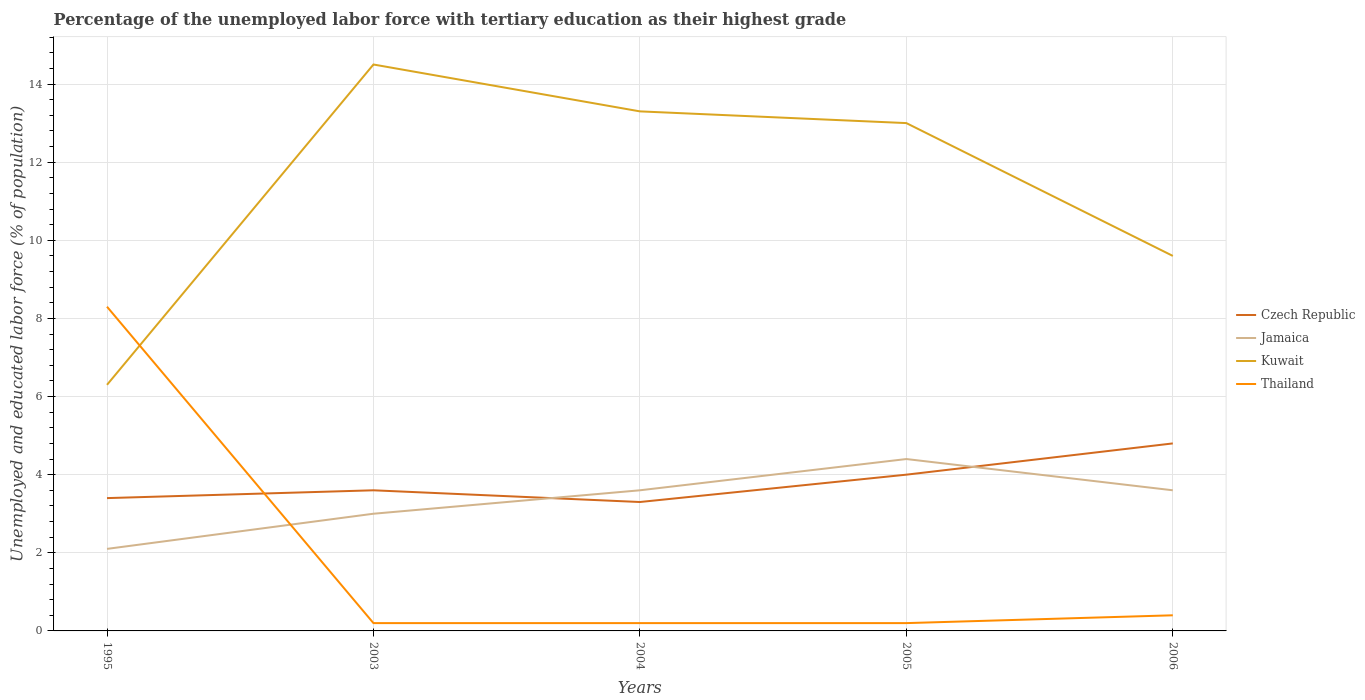How many different coloured lines are there?
Keep it short and to the point. 4. Across all years, what is the maximum percentage of the unemployed labor force with tertiary education in Thailand?
Give a very brief answer. 0.2. In which year was the percentage of the unemployed labor force with tertiary education in Jamaica maximum?
Your response must be concise. 1995. What is the total percentage of the unemployed labor force with tertiary education in Czech Republic in the graph?
Provide a succinct answer. 0.3. What is the difference between the highest and the second highest percentage of the unemployed labor force with tertiary education in Czech Republic?
Your answer should be compact. 1.5. How many years are there in the graph?
Ensure brevity in your answer.  5. Are the values on the major ticks of Y-axis written in scientific E-notation?
Provide a short and direct response. No. How many legend labels are there?
Your response must be concise. 4. What is the title of the graph?
Provide a short and direct response. Percentage of the unemployed labor force with tertiary education as their highest grade. What is the label or title of the X-axis?
Ensure brevity in your answer.  Years. What is the label or title of the Y-axis?
Keep it short and to the point. Unemployed and educated labor force (% of population). What is the Unemployed and educated labor force (% of population) of Czech Republic in 1995?
Keep it short and to the point. 3.4. What is the Unemployed and educated labor force (% of population) of Jamaica in 1995?
Keep it short and to the point. 2.1. What is the Unemployed and educated labor force (% of population) in Kuwait in 1995?
Keep it short and to the point. 6.3. What is the Unemployed and educated labor force (% of population) of Thailand in 1995?
Provide a succinct answer. 8.3. What is the Unemployed and educated labor force (% of population) of Czech Republic in 2003?
Your answer should be compact. 3.6. What is the Unemployed and educated labor force (% of population) in Jamaica in 2003?
Your answer should be very brief. 3. What is the Unemployed and educated labor force (% of population) of Kuwait in 2003?
Keep it short and to the point. 14.5. What is the Unemployed and educated labor force (% of population) of Thailand in 2003?
Keep it short and to the point. 0.2. What is the Unemployed and educated labor force (% of population) in Czech Republic in 2004?
Your response must be concise. 3.3. What is the Unemployed and educated labor force (% of population) of Jamaica in 2004?
Ensure brevity in your answer.  3.6. What is the Unemployed and educated labor force (% of population) of Kuwait in 2004?
Provide a short and direct response. 13.3. What is the Unemployed and educated labor force (% of population) of Thailand in 2004?
Offer a terse response. 0.2. What is the Unemployed and educated labor force (% of population) in Jamaica in 2005?
Your answer should be very brief. 4.4. What is the Unemployed and educated labor force (% of population) in Kuwait in 2005?
Offer a very short reply. 13. What is the Unemployed and educated labor force (% of population) of Thailand in 2005?
Your answer should be very brief. 0.2. What is the Unemployed and educated labor force (% of population) of Czech Republic in 2006?
Offer a terse response. 4.8. What is the Unemployed and educated labor force (% of population) of Jamaica in 2006?
Your answer should be compact. 3.6. What is the Unemployed and educated labor force (% of population) of Kuwait in 2006?
Provide a succinct answer. 9.6. What is the Unemployed and educated labor force (% of population) in Thailand in 2006?
Your answer should be compact. 0.4. Across all years, what is the maximum Unemployed and educated labor force (% of population) of Czech Republic?
Keep it short and to the point. 4.8. Across all years, what is the maximum Unemployed and educated labor force (% of population) of Jamaica?
Provide a succinct answer. 4.4. Across all years, what is the maximum Unemployed and educated labor force (% of population) in Kuwait?
Your answer should be compact. 14.5. Across all years, what is the maximum Unemployed and educated labor force (% of population) of Thailand?
Provide a succinct answer. 8.3. Across all years, what is the minimum Unemployed and educated labor force (% of population) in Czech Republic?
Offer a very short reply. 3.3. Across all years, what is the minimum Unemployed and educated labor force (% of population) of Jamaica?
Your answer should be very brief. 2.1. Across all years, what is the minimum Unemployed and educated labor force (% of population) in Kuwait?
Provide a succinct answer. 6.3. Across all years, what is the minimum Unemployed and educated labor force (% of population) of Thailand?
Make the answer very short. 0.2. What is the total Unemployed and educated labor force (% of population) in Jamaica in the graph?
Keep it short and to the point. 16.7. What is the total Unemployed and educated labor force (% of population) of Kuwait in the graph?
Provide a short and direct response. 56.7. What is the difference between the Unemployed and educated labor force (% of population) in Czech Republic in 1995 and that in 2003?
Give a very brief answer. -0.2. What is the difference between the Unemployed and educated labor force (% of population) in Czech Republic in 1995 and that in 2004?
Your answer should be very brief. 0.1. What is the difference between the Unemployed and educated labor force (% of population) of Jamaica in 1995 and that in 2004?
Make the answer very short. -1.5. What is the difference between the Unemployed and educated labor force (% of population) in Kuwait in 1995 and that in 2005?
Give a very brief answer. -6.7. What is the difference between the Unemployed and educated labor force (% of population) in Czech Republic in 1995 and that in 2006?
Provide a succinct answer. -1.4. What is the difference between the Unemployed and educated labor force (% of population) in Jamaica in 1995 and that in 2006?
Your answer should be compact. -1.5. What is the difference between the Unemployed and educated labor force (% of population) of Czech Republic in 2003 and that in 2004?
Give a very brief answer. 0.3. What is the difference between the Unemployed and educated labor force (% of population) of Czech Republic in 2003 and that in 2005?
Provide a succinct answer. -0.4. What is the difference between the Unemployed and educated labor force (% of population) in Kuwait in 2003 and that in 2005?
Provide a short and direct response. 1.5. What is the difference between the Unemployed and educated labor force (% of population) of Thailand in 2003 and that in 2005?
Your response must be concise. 0. What is the difference between the Unemployed and educated labor force (% of population) in Czech Republic in 2003 and that in 2006?
Your answer should be compact. -1.2. What is the difference between the Unemployed and educated labor force (% of population) in Jamaica in 2003 and that in 2006?
Give a very brief answer. -0.6. What is the difference between the Unemployed and educated labor force (% of population) of Thailand in 2003 and that in 2006?
Your answer should be very brief. -0.2. What is the difference between the Unemployed and educated labor force (% of population) in Czech Republic in 2004 and that in 2005?
Provide a short and direct response. -0.7. What is the difference between the Unemployed and educated labor force (% of population) in Kuwait in 2004 and that in 2005?
Offer a very short reply. 0.3. What is the difference between the Unemployed and educated labor force (% of population) in Jamaica in 2004 and that in 2006?
Keep it short and to the point. 0. What is the difference between the Unemployed and educated labor force (% of population) of Kuwait in 2004 and that in 2006?
Your answer should be compact. 3.7. What is the difference between the Unemployed and educated labor force (% of population) of Jamaica in 2005 and that in 2006?
Your response must be concise. 0.8. What is the difference between the Unemployed and educated labor force (% of population) of Thailand in 2005 and that in 2006?
Ensure brevity in your answer.  -0.2. What is the difference between the Unemployed and educated labor force (% of population) in Czech Republic in 1995 and the Unemployed and educated labor force (% of population) in Jamaica in 2003?
Provide a short and direct response. 0.4. What is the difference between the Unemployed and educated labor force (% of population) in Czech Republic in 1995 and the Unemployed and educated labor force (% of population) in Kuwait in 2003?
Ensure brevity in your answer.  -11.1. What is the difference between the Unemployed and educated labor force (% of population) of Jamaica in 1995 and the Unemployed and educated labor force (% of population) of Thailand in 2003?
Provide a succinct answer. 1.9. What is the difference between the Unemployed and educated labor force (% of population) of Czech Republic in 1995 and the Unemployed and educated labor force (% of population) of Thailand in 2004?
Your answer should be very brief. 3.2. What is the difference between the Unemployed and educated labor force (% of population) in Jamaica in 1995 and the Unemployed and educated labor force (% of population) in Kuwait in 2004?
Give a very brief answer. -11.2. What is the difference between the Unemployed and educated labor force (% of population) in Kuwait in 1995 and the Unemployed and educated labor force (% of population) in Thailand in 2004?
Keep it short and to the point. 6.1. What is the difference between the Unemployed and educated labor force (% of population) in Czech Republic in 1995 and the Unemployed and educated labor force (% of population) in Jamaica in 2005?
Provide a short and direct response. -1. What is the difference between the Unemployed and educated labor force (% of population) of Jamaica in 1995 and the Unemployed and educated labor force (% of population) of Kuwait in 2005?
Offer a terse response. -10.9. What is the difference between the Unemployed and educated labor force (% of population) in Jamaica in 1995 and the Unemployed and educated labor force (% of population) in Thailand in 2005?
Keep it short and to the point. 1.9. What is the difference between the Unemployed and educated labor force (% of population) of Kuwait in 1995 and the Unemployed and educated labor force (% of population) of Thailand in 2005?
Ensure brevity in your answer.  6.1. What is the difference between the Unemployed and educated labor force (% of population) of Czech Republic in 1995 and the Unemployed and educated labor force (% of population) of Jamaica in 2006?
Make the answer very short. -0.2. What is the difference between the Unemployed and educated labor force (% of population) of Czech Republic in 1995 and the Unemployed and educated labor force (% of population) of Kuwait in 2006?
Provide a short and direct response. -6.2. What is the difference between the Unemployed and educated labor force (% of population) of Czech Republic in 1995 and the Unemployed and educated labor force (% of population) of Thailand in 2006?
Provide a succinct answer. 3. What is the difference between the Unemployed and educated labor force (% of population) in Jamaica in 1995 and the Unemployed and educated labor force (% of population) in Kuwait in 2006?
Your answer should be very brief. -7.5. What is the difference between the Unemployed and educated labor force (% of population) of Kuwait in 1995 and the Unemployed and educated labor force (% of population) of Thailand in 2006?
Make the answer very short. 5.9. What is the difference between the Unemployed and educated labor force (% of population) of Czech Republic in 2003 and the Unemployed and educated labor force (% of population) of Jamaica in 2004?
Provide a succinct answer. 0. What is the difference between the Unemployed and educated labor force (% of population) of Czech Republic in 2003 and the Unemployed and educated labor force (% of population) of Kuwait in 2004?
Provide a short and direct response. -9.7. What is the difference between the Unemployed and educated labor force (% of population) of Jamaica in 2003 and the Unemployed and educated labor force (% of population) of Thailand in 2004?
Your answer should be very brief. 2.8. What is the difference between the Unemployed and educated labor force (% of population) of Czech Republic in 2003 and the Unemployed and educated labor force (% of population) of Kuwait in 2005?
Make the answer very short. -9.4. What is the difference between the Unemployed and educated labor force (% of population) of Jamaica in 2003 and the Unemployed and educated labor force (% of population) of Kuwait in 2005?
Give a very brief answer. -10. What is the difference between the Unemployed and educated labor force (% of population) of Jamaica in 2003 and the Unemployed and educated labor force (% of population) of Thailand in 2005?
Your answer should be very brief. 2.8. What is the difference between the Unemployed and educated labor force (% of population) in Czech Republic in 2003 and the Unemployed and educated labor force (% of population) in Jamaica in 2006?
Your answer should be compact. 0. What is the difference between the Unemployed and educated labor force (% of population) in Czech Republic in 2003 and the Unemployed and educated labor force (% of population) in Thailand in 2006?
Keep it short and to the point. 3.2. What is the difference between the Unemployed and educated labor force (% of population) of Jamaica in 2003 and the Unemployed and educated labor force (% of population) of Kuwait in 2006?
Keep it short and to the point. -6.6. What is the difference between the Unemployed and educated labor force (% of population) in Kuwait in 2003 and the Unemployed and educated labor force (% of population) in Thailand in 2006?
Make the answer very short. 14.1. What is the difference between the Unemployed and educated labor force (% of population) of Czech Republic in 2004 and the Unemployed and educated labor force (% of population) of Jamaica in 2005?
Provide a succinct answer. -1.1. What is the difference between the Unemployed and educated labor force (% of population) of Czech Republic in 2004 and the Unemployed and educated labor force (% of population) of Thailand in 2005?
Provide a succinct answer. 3.1. What is the difference between the Unemployed and educated labor force (% of population) of Czech Republic in 2004 and the Unemployed and educated labor force (% of population) of Jamaica in 2006?
Keep it short and to the point. -0.3. What is the difference between the Unemployed and educated labor force (% of population) in Czech Republic in 2004 and the Unemployed and educated labor force (% of population) in Kuwait in 2006?
Give a very brief answer. -6.3. What is the difference between the Unemployed and educated labor force (% of population) in Czech Republic in 2004 and the Unemployed and educated labor force (% of population) in Thailand in 2006?
Give a very brief answer. 2.9. What is the difference between the Unemployed and educated labor force (% of population) in Jamaica in 2004 and the Unemployed and educated labor force (% of population) in Kuwait in 2006?
Make the answer very short. -6. What is the difference between the Unemployed and educated labor force (% of population) in Kuwait in 2004 and the Unemployed and educated labor force (% of population) in Thailand in 2006?
Provide a succinct answer. 12.9. What is the difference between the Unemployed and educated labor force (% of population) of Czech Republic in 2005 and the Unemployed and educated labor force (% of population) of Kuwait in 2006?
Your answer should be very brief. -5.6. What is the difference between the Unemployed and educated labor force (% of population) in Czech Republic in 2005 and the Unemployed and educated labor force (% of population) in Thailand in 2006?
Give a very brief answer. 3.6. What is the difference between the Unemployed and educated labor force (% of population) in Jamaica in 2005 and the Unemployed and educated labor force (% of population) in Kuwait in 2006?
Give a very brief answer. -5.2. What is the average Unemployed and educated labor force (% of population) in Czech Republic per year?
Offer a terse response. 3.82. What is the average Unemployed and educated labor force (% of population) of Jamaica per year?
Your response must be concise. 3.34. What is the average Unemployed and educated labor force (% of population) of Kuwait per year?
Make the answer very short. 11.34. What is the average Unemployed and educated labor force (% of population) in Thailand per year?
Your response must be concise. 1.86. In the year 1995, what is the difference between the Unemployed and educated labor force (% of population) in Czech Republic and Unemployed and educated labor force (% of population) in Thailand?
Keep it short and to the point. -4.9. In the year 1995, what is the difference between the Unemployed and educated labor force (% of population) in Jamaica and Unemployed and educated labor force (% of population) in Kuwait?
Provide a short and direct response. -4.2. In the year 1995, what is the difference between the Unemployed and educated labor force (% of population) in Kuwait and Unemployed and educated labor force (% of population) in Thailand?
Offer a very short reply. -2. In the year 2003, what is the difference between the Unemployed and educated labor force (% of population) of Czech Republic and Unemployed and educated labor force (% of population) of Jamaica?
Provide a short and direct response. 0.6. In the year 2003, what is the difference between the Unemployed and educated labor force (% of population) of Czech Republic and Unemployed and educated labor force (% of population) of Kuwait?
Provide a succinct answer. -10.9. In the year 2004, what is the difference between the Unemployed and educated labor force (% of population) of Czech Republic and Unemployed and educated labor force (% of population) of Jamaica?
Provide a short and direct response. -0.3. In the year 2004, what is the difference between the Unemployed and educated labor force (% of population) of Czech Republic and Unemployed and educated labor force (% of population) of Kuwait?
Ensure brevity in your answer.  -10. In the year 2004, what is the difference between the Unemployed and educated labor force (% of population) in Czech Republic and Unemployed and educated labor force (% of population) in Thailand?
Offer a terse response. 3.1. In the year 2004, what is the difference between the Unemployed and educated labor force (% of population) of Jamaica and Unemployed and educated labor force (% of population) of Kuwait?
Ensure brevity in your answer.  -9.7. In the year 2004, what is the difference between the Unemployed and educated labor force (% of population) of Jamaica and Unemployed and educated labor force (% of population) of Thailand?
Offer a terse response. 3.4. In the year 2006, what is the difference between the Unemployed and educated labor force (% of population) in Czech Republic and Unemployed and educated labor force (% of population) in Jamaica?
Your answer should be very brief. 1.2. In the year 2006, what is the difference between the Unemployed and educated labor force (% of population) in Czech Republic and Unemployed and educated labor force (% of population) in Kuwait?
Your answer should be compact. -4.8. In the year 2006, what is the difference between the Unemployed and educated labor force (% of population) of Jamaica and Unemployed and educated labor force (% of population) of Kuwait?
Provide a succinct answer. -6. What is the ratio of the Unemployed and educated labor force (% of population) of Czech Republic in 1995 to that in 2003?
Your response must be concise. 0.94. What is the ratio of the Unemployed and educated labor force (% of population) in Kuwait in 1995 to that in 2003?
Offer a very short reply. 0.43. What is the ratio of the Unemployed and educated labor force (% of population) of Thailand in 1995 to that in 2003?
Offer a terse response. 41.5. What is the ratio of the Unemployed and educated labor force (% of population) in Czech Republic in 1995 to that in 2004?
Offer a terse response. 1.03. What is the ratio of the Unemployed and educated labor force (% of population) in Jamaica in 1995 to that in 2004?
Give a very brief answer. 0.58. What is the ratio of the Unemployed and educated labor force (% of population) of Kuwait in 1995 to that in 2004?
Provide a succinct answer. 0.47. What is the ratio of the Unemployed and educated labor force (% of population) in Thailand in 1995 to that in 2004?
Provide a succinct answer. 41.5. What is the ratio of the Unemployed and educated labor force (% of population) in Jamaica in 1995 to that in 2005?
Your answer should be compact. 0.48. What is the ratio of the Unemployed and educated labor force (% of population) in Kuwait in 1995 to that in 2005?
Offer a terse response. 0.48. What is the ratio of the Unemployed and educated labor force (% of population) in Thailand in 1995 to that in 2005?
Give a very brief answer. 41.5. What is the ratio of the Unemployed and educated labor force (% of population) in Czech Republic in 1995 to that in 2006?
Your answer should be very brief. 0.71. What is the ratio of the Unemployed and educated labor force (% of population) of Jamaica in 1995 to that in 2006?
Ensure brevity in your answer.  0.58. What is the ratio of the Unemployed and educated labor force (% of population) of Kuwait in 1995 to that in 2006?
Offer a terse response. 0.66. What is the ratio of the Unemployed and educated labor force (% of population) of Thailand in 1995 to that in 2006?
Offer a very short reply. 20.75. What is the ratio of the Unemployed and educated labor force (% of population) in Jamaica in 2003 to that in 2004?
Offer a terse response. 0.83. What is the ratio of the Unemployed and educated labor force (% of population) of Kuwait in 2003 to that in 2004?
Offer a terse response. 1.09. What is the ratio of the Unemployed and educated labor force (% of population) in Czech Republic in 2003 to that in 2005?
Make the answer very short. 0.9. What is the ratio of the Unemployed and educated labor force (% of population) of Jamaica in 2003 to that in 2005?
Provide a succinct answer. 0.68. What is the ratio of the Unemployed and educated labor force (% of population) of Kuwait in 2003 to that in 2005?
Your response must be concise. 1.12. What is the ratio of the Unemployed and educated labor force (% of population) in Thailand in 2003 to that in 2005?
Provide a short and direct response. 1. What is the ratio of the Unemployed and educated labor force (% of population) of Czech Republic in 2003 to that in 2006?
Offer a terse response. 0.75. What is the ratio of the Unemployed and educated labor force (% of population) of Jamaica in 2003 to that in 2006?
Offer a terse response. 0.83. What is the ratio of the Unemployed and educated labor force (% of population) in Kuwait in 2003 to that in 2006?
Keep it short and to the point. 1.51. What is the ratio of the Unemployed and educated labor force (% of population) of Czech Republic in 2004 to that in 2005?
Give a very brief answer. 0.82. What is the ratio of the Unemployed and educated labor force (% of population) of Jamaica in 2004 to that in 2005?
Give a very brief answer. 0.82. What is the ratio of the Unemployed and educated labor force (% of population) in Kuwait in 2004 to that in 2005?
Make the answer very short. 1.02. What is the ratio of the Unemployed and educated labor force (% of population) of Thailand in 2004 to that in 2005?
Give a very brief answer. 1. What is the ratio of the Unemployed and educated labor force (% of population) in Czech Republic in 2004 to that in 2006?
Keep it short and to the point. 0.69. What is the ratio of the Unemployed and educated labor force (% of population) of Jamaica in 2004 to that in 2006?
Make the answer very short. 1. What is the ratio of the Unemployed and educated labor force (% of population) in Kuwait in 2004 to that in 2006?
Provide a succinct answer. 1.39. What is the ratio of the Unemployed and educated labor force (% of population) in Thailand in 2004 to that in 2006?
Your answer should be very brief. 0.5. What is the ratio of the Unemployed and educated labor force (% of population) of Czech Republic in 2005 to that in 2006?
Give a very brief answer. 0.83. What is the ratio of the Unemployed and educated labor force (% of population) of Jamaica in 2005 to that in 2006?
Make the answer very short. 1.22. What is the ratio of the Unemployed and educated labor force (% of population) of Kuwait in 2005 to that in 2006?
Ensure brevity in your answer.  1.35. What is the difference between the highest and the second highest Unemployed and educated labor force (% of population) of Jamaica?
Your response must be concise. 0.8. What is the difference between the highest and the lowest Unemployed and educated labor force (% of population) of Czech Republic?
Keep it short and to the point. 1.5. What is the difference between the highest and the lowest Unemployed and educated labor force (% of population) of Kuwait?
Ensure brevity in your answer.  8.2. What is the difference between the highest and the lowest Unemployed and educated labor force (% of population) in Thailand?
Give a very brief answer. 8.1. 